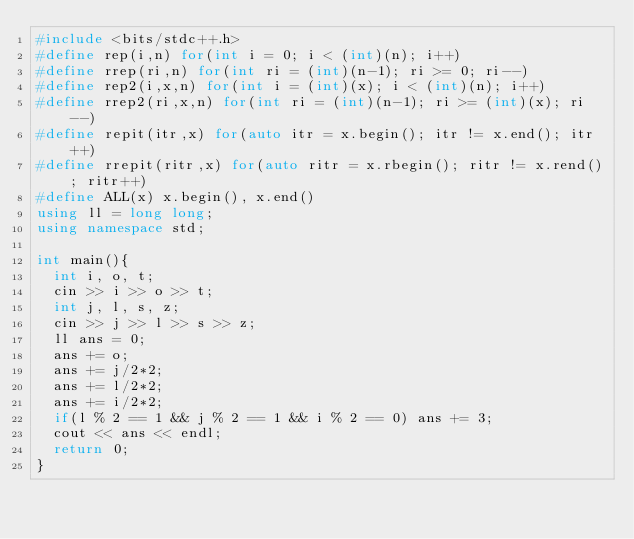Convert code to text. <code><loc_0><loc_0><loc_500><loc_500><_C++_>#include <bits/stdc++.h>
#define rep(i,n) for(int i = 0; i < (int)(n); i++)
#define rrep(ri,n) for(int ri = (int)(n-1); ri >= 0; ri--)
#define rep2(i,x,n) for(int i = (int)(x); i < (int)(n); i++)
#define rrep2(ri,x,n) for(int ri = (int)(n-1); ri >= (int)(x); ri--)
#define repit(itr,x) for(auto itr = x.begin(); itr != x.end(); itr++)
#define rrepit(ritr,x) for(auto ritr = x.rbegin(); ritr != x.rend(); ritr++)
#define ALL(x) x.begin(), x.end()
using ll = long long;
using namespace std;

int main(){
  int i, o, t;
  cin >> i >> o >> t;
  int j, l, s, z;
  cin >> j >> l >> s >> z;
  ll ans = 0;
  ans += o;
  ans += j/2*2;
  ans += l/2*2;
  ans += i/2*2;
  if(l % 2 == 1 && j % 2 == 1 && i % 2 == 0) ans += 3;
  cout << ans << endl;
  return 0;
}</code> 